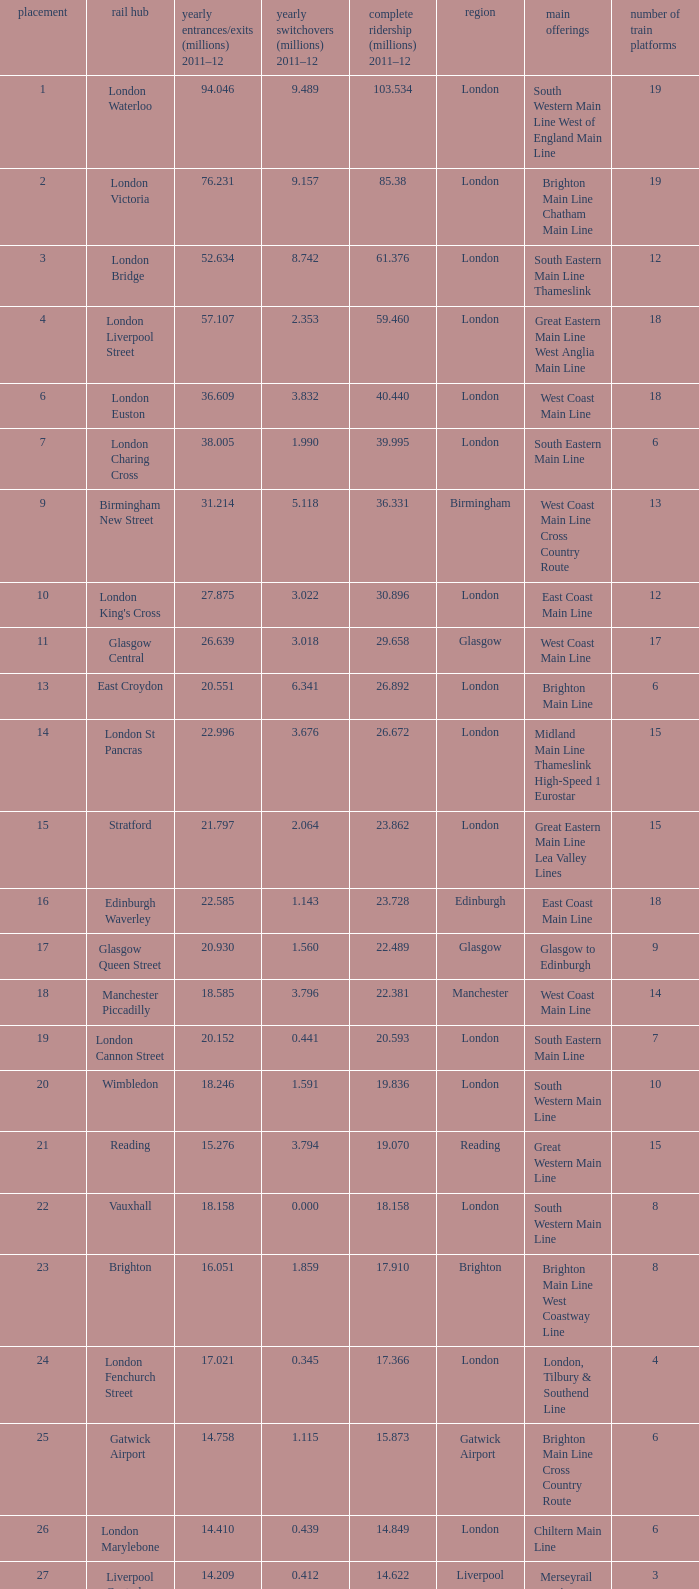How many annual interchanges in the millions occurred in 2011-12 when the number of annual entry/exits was 36.609 million?  3.832. 